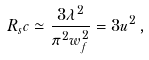Convert formula to latex. <formula><loc_0><loc_0><loc_500><loc_500>R _ { s } c \simeq \frac { 3 \lambda ^ { 2 } } { \pi ^ { 2 } w _ { f } ^ { 2 } } = 3 u ^ { 2 } \, ,</formula> 